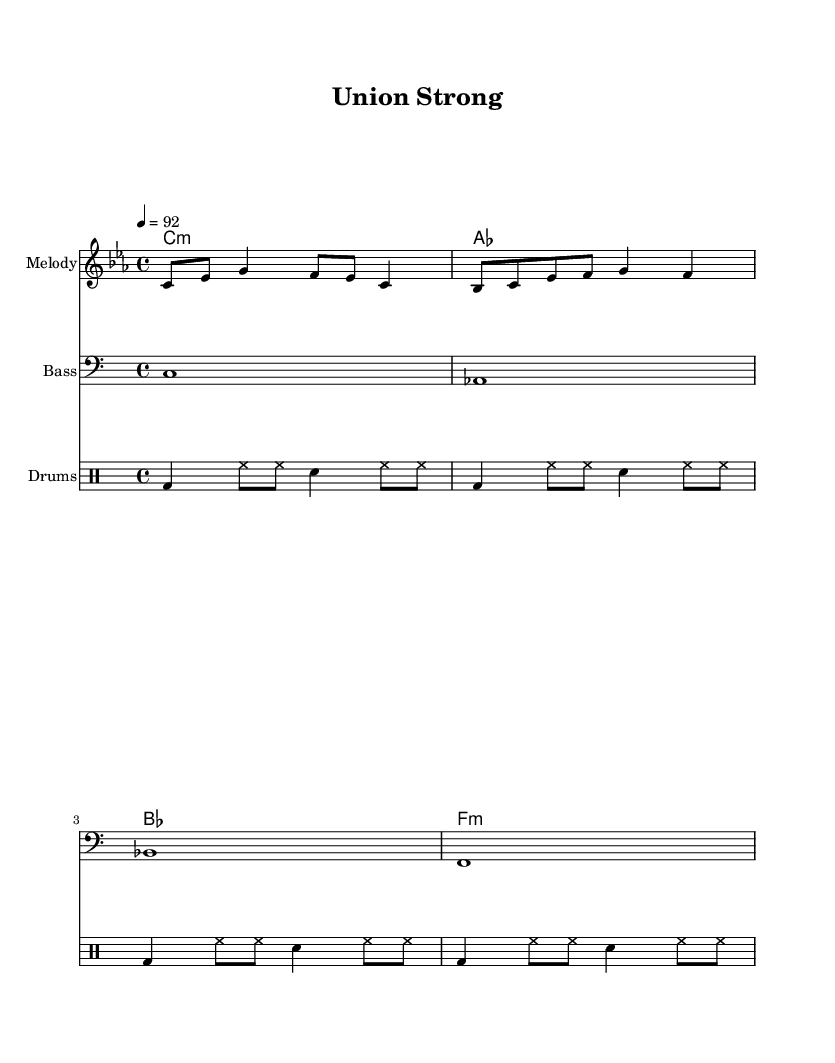What is the key signature of this music? The key signature is C minor, which has three flats (B flat, E flat, and A flat). This can be determined by looking at the key signature shown at the beginning of the staff.
Answer: C minor What is the time signature of this music? The time signature is 4/4, indicated by the notation at the beginning of the score. This denotes that there are four beats per measure and the quarter note gets one beat.
Answer: 4/4 What is the tempo marking for this piece? The tempo marking is set to 92 beats per minute, indicated in the score by "4 = 92". This suggests a moderate pace for the music performance.
Answer: 92 How many measures are in the melody section? There are four measures in the melody section, as indicated by the repeated structure of the notes written in each line.
Answer: 4 What is the primary theme addressed in the lyrics? The primary theme in the lyrics focuses on unity and the fight for fair wages, which is a common issue related to workplace equality, as expressed clearly in the text.
Answer: Fair wages What is the style of this music? The style of this music is best described as Rap, which typically incorporates rhythms and rhymes addressing social issues, as reflected in the content and delivery of the lyrics.
Answer: Rap What instruments are featured in this score? The instruments featured in this score are piano (melody), bass, and drums, as indicated by the labels in the respective staves of the sheet music.
Answer: Piano, Bass, Drums 